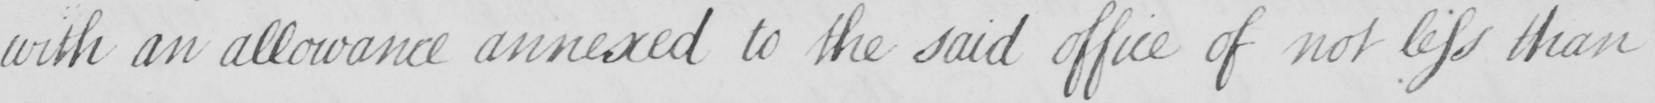What does this handwritten line say? with an allowance annexed to the said office of not less than 